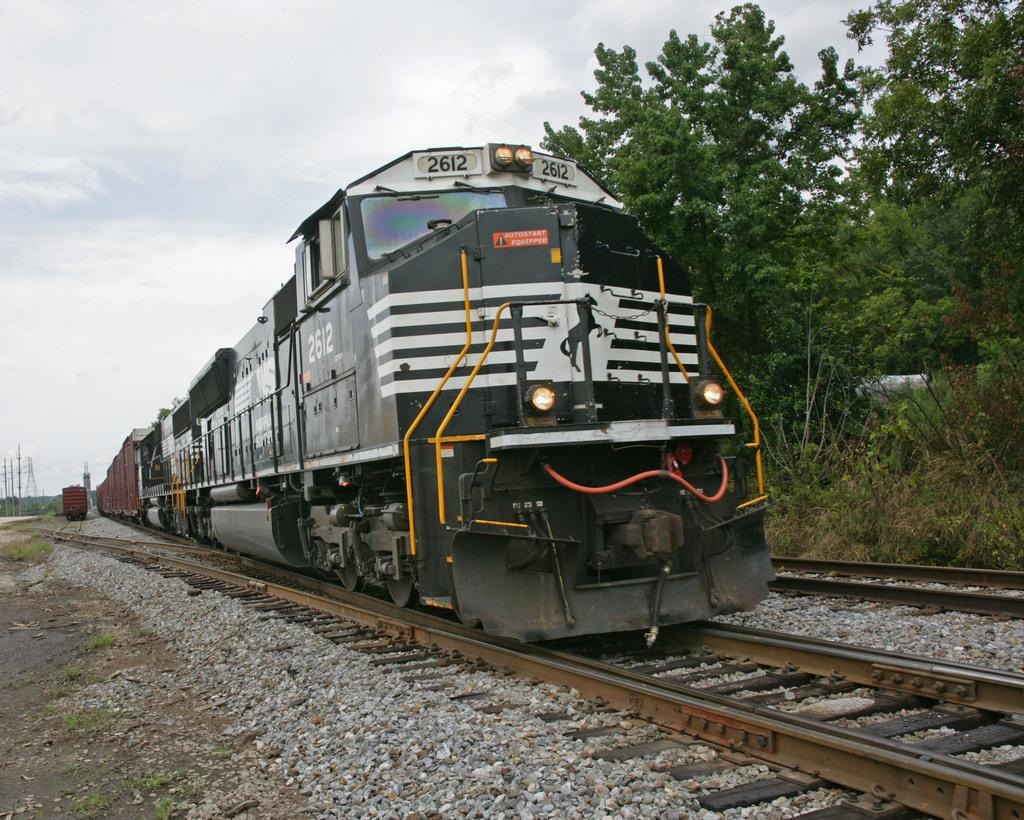What is the main subject of the image? The main subject of the image is a train. Where is the train located in the image? The train is on a railway track. What can be seen on the ground in the image? There are stones on the ground in the image. What type of vegetation is on the right side of the image? There are trees on the right side of the image. What is visible at the top of the image? The sky is visible at the top of the image. What type of music can be heard coming from the shelf in the image? There is no shelf present in the image, and therefore no music can be heard coming from it. 